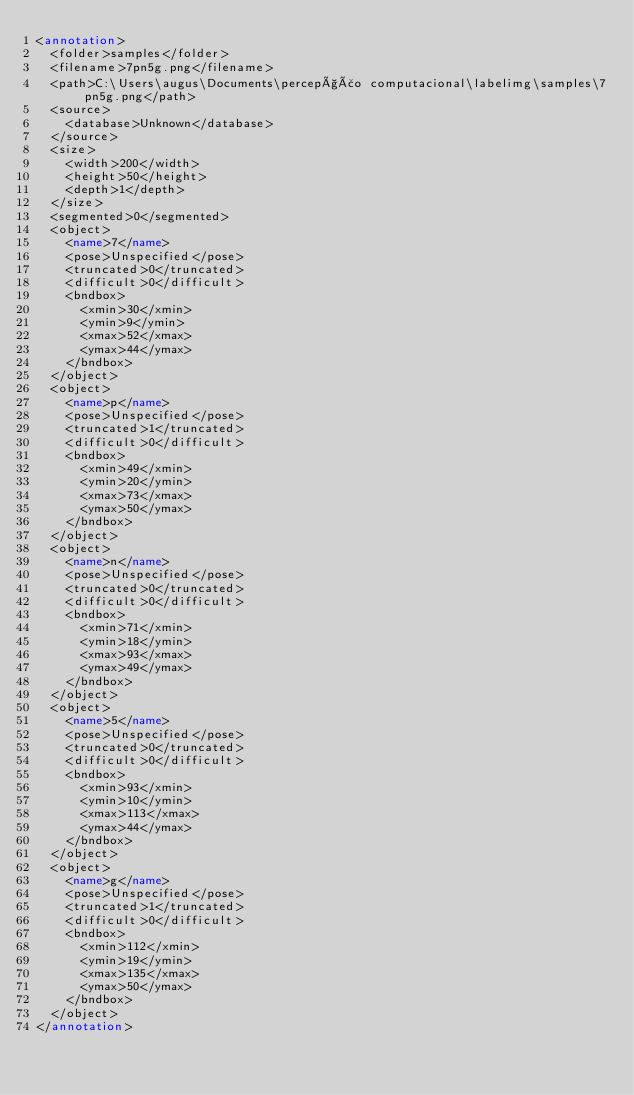<code> <loc_0><loc_0><loc_500><loc_500><_XML_><annotation>
	<folder>samples</folder>
	<filename>7pn5g.png</filename>
	<path>C:\Users\augus\Documents\percepção computacional\labelimg\samples\7pn5g.png</path>
	<source>
		<database>Unknown</database>
	</source>
	<size>
		<width>200</width>
		<height>50</height>
		<depth>1</depth>
	</size>
	<segmented>0</segmented>
	<object>
		<name>7</name>
		<pose>Unspecified</pose>
		<truncated>0</truncated>
		<difficult>0</difficult>
		<bndbox>
			<xmin>30</xmin>
			<ymin>9</ymin>
			<xmax>52</xmax>
			<ymax>44</ymax>
		</bndbox>
	</object>
	<object>
		<name>p</name>
		<pose>Unspecified</pose>
		<truncated>1</truncated>
		<difficult>0</difficult>
		<bndbox>
			<xmin>49</xmin>
			<ymin>20</ymin>
			<xmax>73</xmax>
			<ymax>50</ymax>
		</bndbox>
	</object>
	<object>
		<name>n</name>
		<pose>Unspecified</pose>
		<truncated>0</truncated>
		<difficult>0</difficult>
		<bndbox>
			<xmin>71</xmin>
			<ymin>18</ymin>
			<xmax>93</xmax>
			<ymax>49</ymax>
		</bndbox>
	</object>
	<object>
		<name>5</name>
		<pose>Unspecified</pose>
		<truncated>0</truncated>
		<difficult>0</difficult>
		<bndbox>
			<xmin>93</xmin>
			<ymin>10</ymin>
			<xmax>113</xmax>
			<ymax>44</ymax>
		</bndbox>
	</object>
	<object>
		<name>g</name>
		<pose>Unspecified</pose>
		<truncated>1</truncated>
		<difficult>0</difficult>
		<bndbox>
			<xmin>112</xmin>
			<ymin>19</ymin>
			<xmax>135</xmax>
			<ymax>50</ymax>
		</bndbox>
	</object>
</annotation>
</code> 